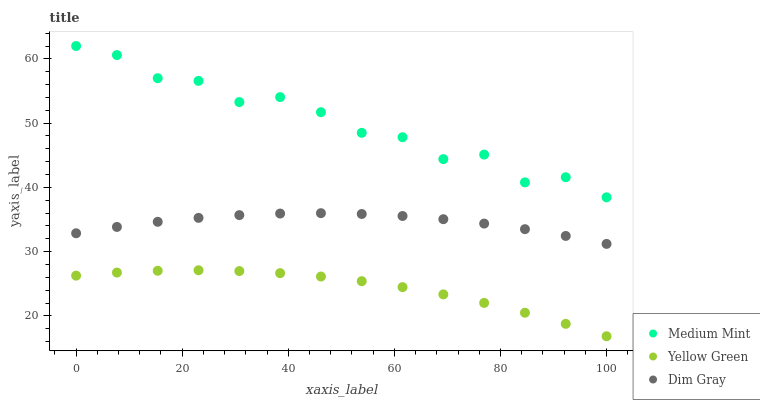Does Yellow Green have the minimum area under the curve?
Answer yes or no. Yes. Does Medium Mint have the maximum area under the curve?
Answer yes or no. Yes. Does Dim Gray have the minimum area under the curve?
Answer yes or no. No. Does Dim Gray have the maximum area under the curve?
Answer yes or no. No. Is Dim Gray the smoothest?
Answer yes or no. Yes. Is Medium Mint the roughest?
Answer yes or no. Yes. Is Yellow Green the smoothest?
Answer yes or no. No. Is Yellow Green the roughest?
Answer yes or no. No. Does Yellow Green have the lowest value?
Answer yes or no. Yes. Does Dim Gray have the lowest value?
Answer yes or no. No. Does Medium Mint have the highest value?
Answer yes or no. Yes. Does Dim Gray have the highest value?
Answer yes or no. No. Is Yellow Green less than Dim Gray?
Answer yes or no. Yes. Is Medium Mint greater than Dim Gray?
Answer yes or no. Yes. Does Yellow Green intersect Dim Gray?
Answer yes or no. No. 